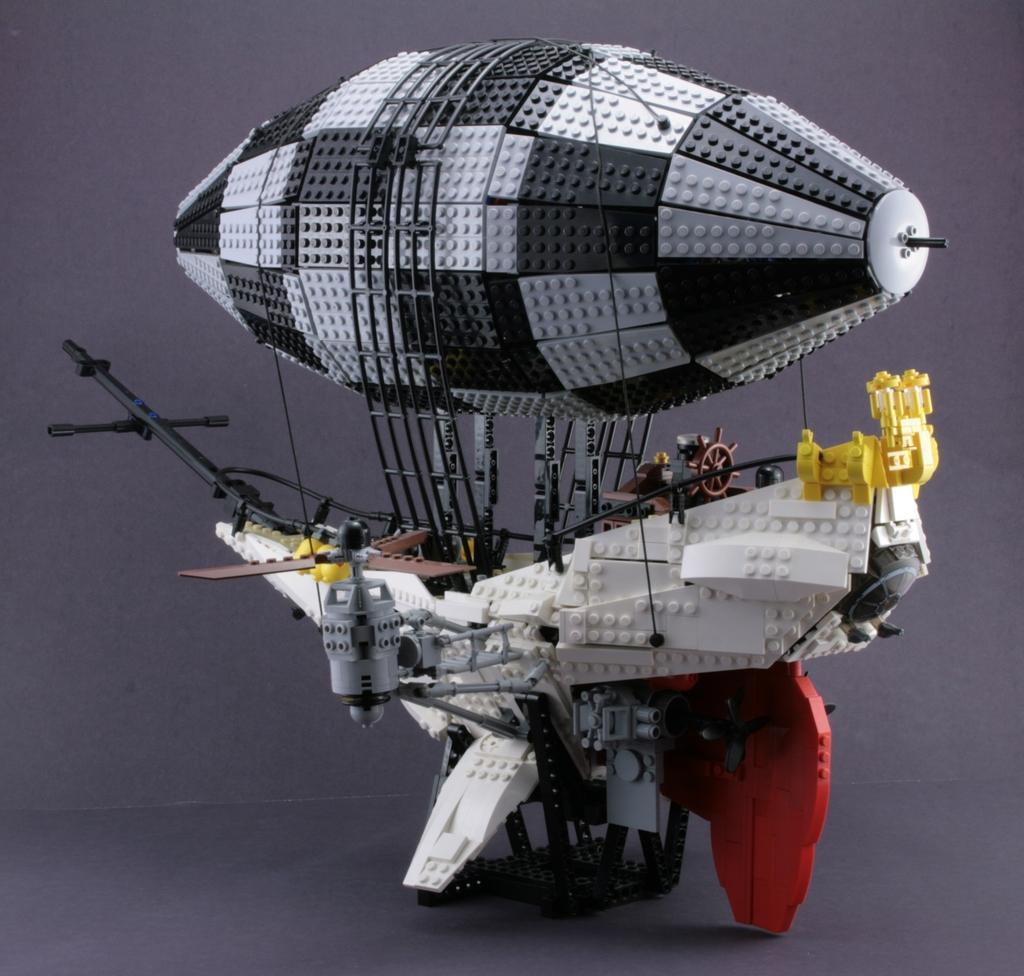In one or two sentences, can you explain what this image depicts? There is a lego airship. It has a fan at the left and a parachute. 